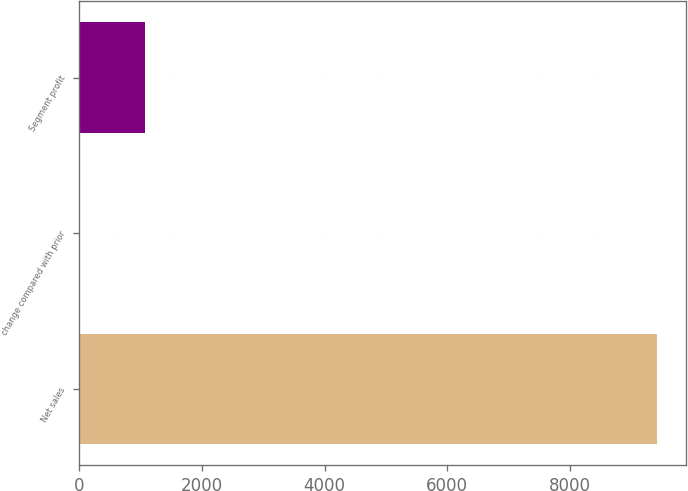Convert chart to OTSL. <chart><loc_0><loc_0><loc_500><loc_500><bar_chart><fcel>Net sales<fcel>change compared with prior<fcel>Segment profit<nl><fcel>9416<fcel>17<fcel>1065<nl></chart> 